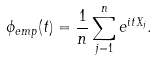Convert formula to latex. <formula><loc_0><loc_0><loc_500><loc_500>\phi _ { e m p } ( t ) = \frac { 1 } { n } \sum _ { j = 1 } ^ { n } e ^ { i t X _ { j } } .</formula> 